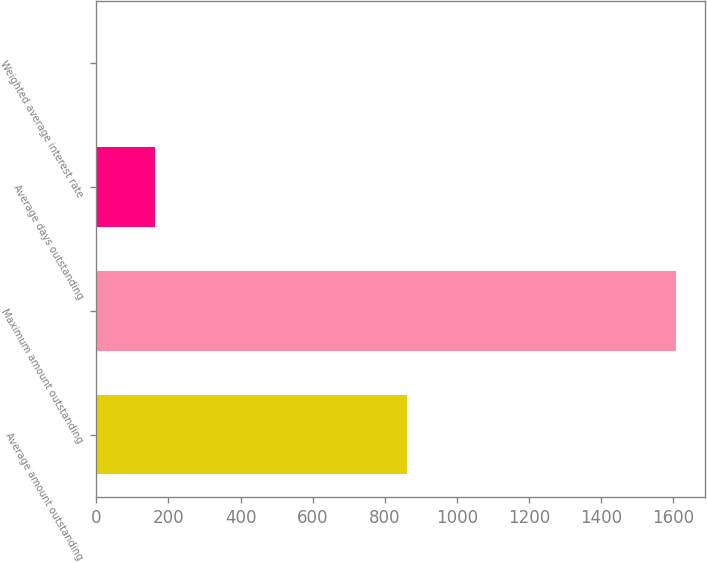Convert chart. <chart><loc_0><loc_0><loc_500><loc_500><bar_chart><fcel>Average amount outstanding<fcel>Maximum amount outstanding<fcel>Average days outstanding<fcel>Weighted average interest rate<nl><fcel>861.3<fcel>1608.9<fcel>161.52<fcel>0.7<nl></chart> 